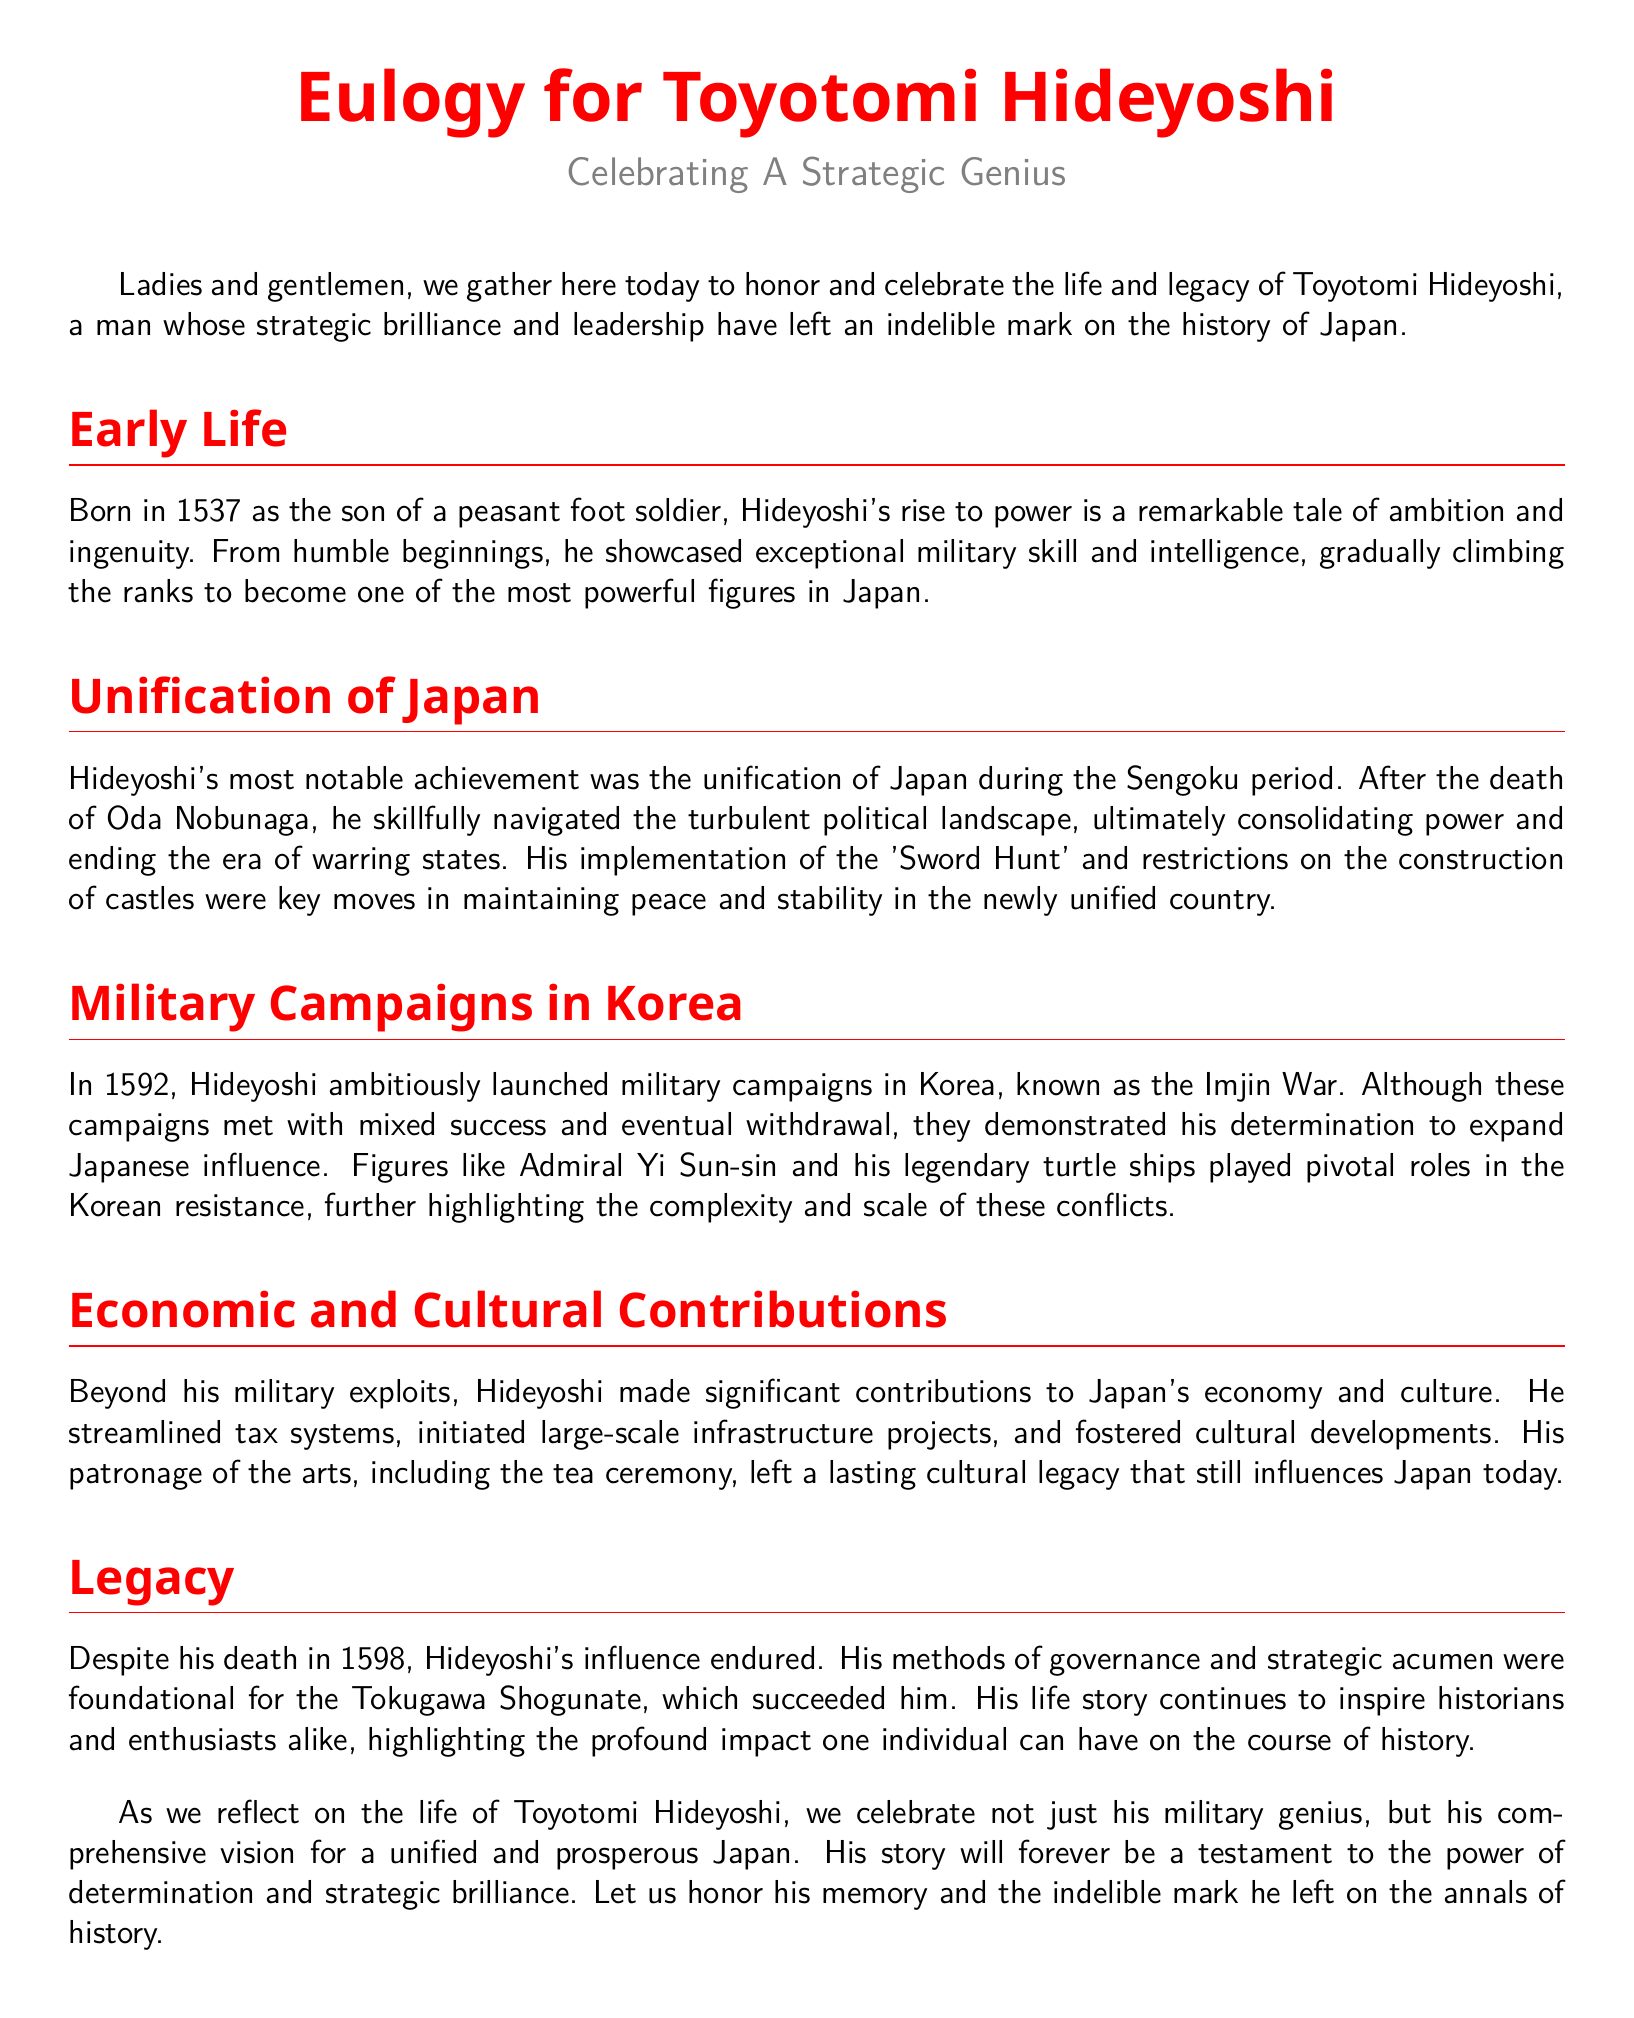What year was Toyotomi Hideyoshi born? The document states that Hideyoshi was born in 1537.
Answer: 1537 What significant period did Hideyoshi unify Japan? The Eulogy mentions that Hideyoshi unified Japan during the Sengoku period.
Answer: Sengoku period What military campaign did Hideyoshi launch in 1592? The document refers to the military campaigns in Korea, known as the Imjin War.
Answer: Imjin War Which naval figure is highlighted in the Korean resistance? The Eulogy mentions Admiral Yi Sun-sin as a key figure in the resistance.
Answer: Admiral Yi Sun-sin What cultural practice was notably influenced by Hideyoshi? The document mentions the tea ceremony as part of Hideyoshi's cultural contributions.
Answer: Tea ceremony What was one of Hideyoshi's methods to maintain peace in Japan? The Eulogy describes the implementation of the 'Sword Hunt' as a key move for peace.
Answer: Sword Hunt When did Toyotomi Hideyoshi pass away? The document states that Hideyoshi died in 1598.
Answer: 1598 What was a foundation for the Tokugawa Shogunate according to the Eulogy? The Eulogy suggests that Hideyoshi's methods of governance influenced the Tokugawa Shogunate.
Answer: Methods of governance What does the Eulogy ultimately celebrate about Hideyoshi? The document concludes by celebrating Hideyoshi's military genius as well as his vision for a unified Japan.
Answer: Military genius and vision 